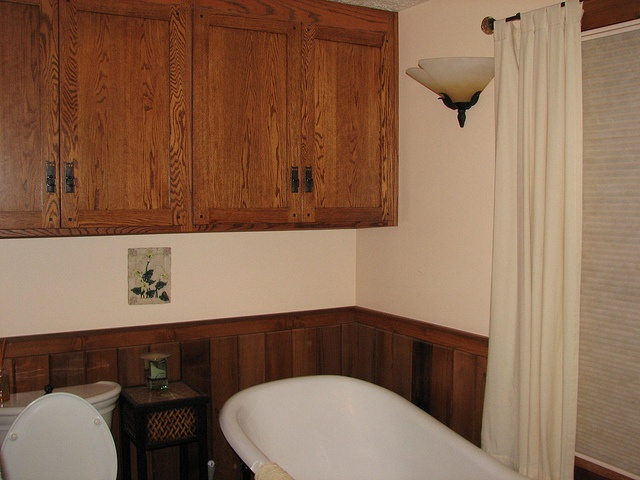Describe the objects in this image and their specific colors. I can see sink in black, darkgray, and gray tones, toilet in black, darkgray, gray, and brown tones, and cup in black and darkgreen tones in this image. 